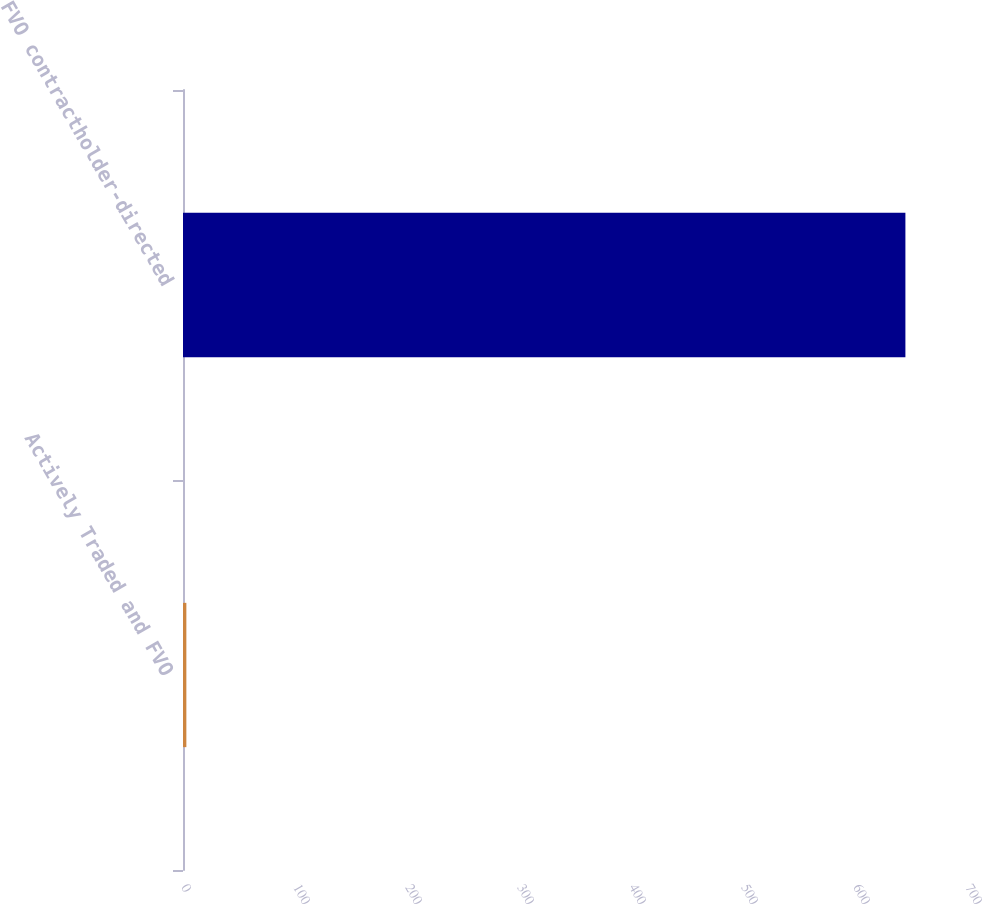Convert chart. <chart><loc_0><loc_0><loc_500><loc_500><bar_chart><fcel>Actively Traded and FVO<fcel>FVO contractholder-directed<nl><fcel>3<fcel>645<nl></chart> 